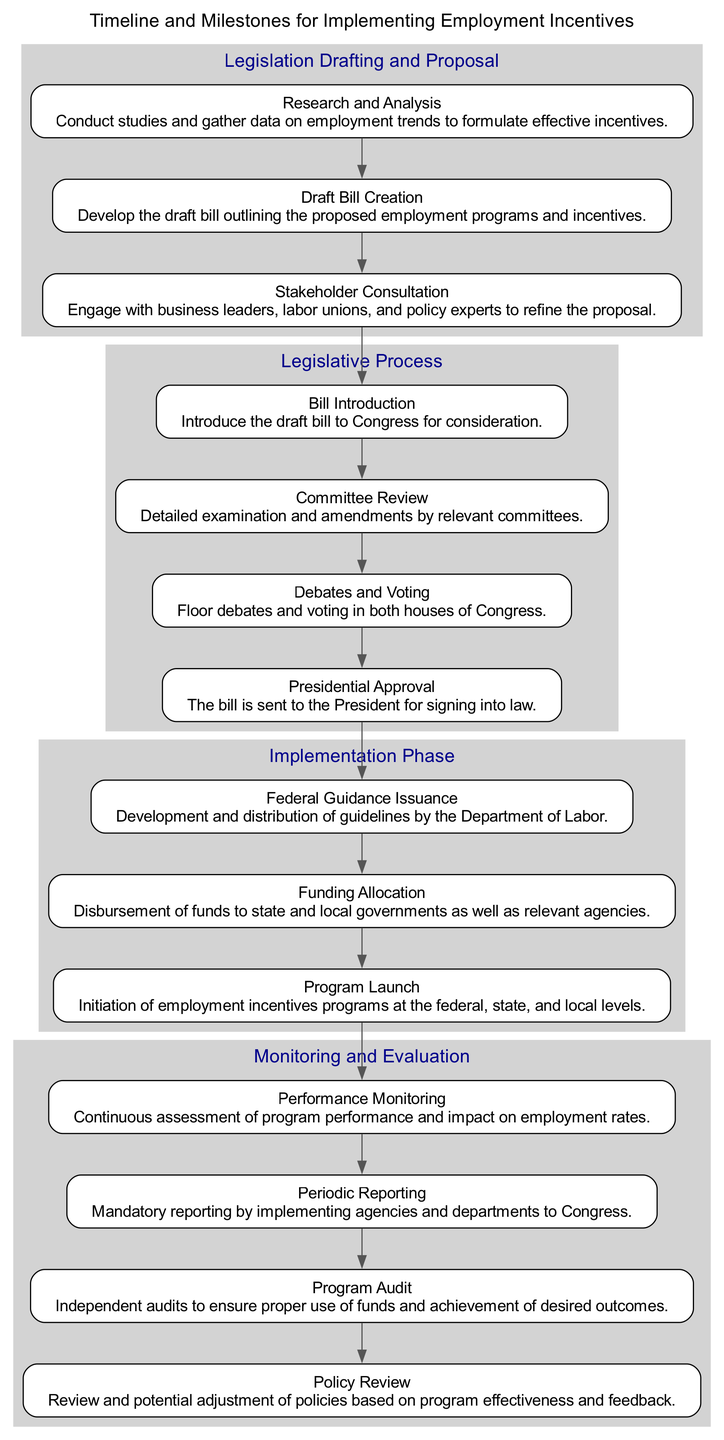What is the first milestone in the "Legislation Drafting and Proposal" block? The first milestone listed under the "Legislation Drafting and Proposal" block is "Research and Analysis." It is the first entry in the milestones array for that block.
Answer: Research and Analysis How many blocks are present in this diagram? There are four distinct blocks in the diagram, each representing a different phase of the process: "Legislation Drafting and Proposal," "Legislative Process," "Implementation Phase," and "Monitoring and Evaluation." Each block is visually separated in the diagram.
Answer: 4 What connects the last milestone of one block to the first milestone of the next block? The connection from the last milestone of one block to the first milestone of the next block is represented by directed edges. In this case, an edge connects the last milestone of "Legislation Drafting and Proposal" to the first milestone of "Legislative Process."
Answer: Directed edge Which milestone in the "Implementation Phase" involves the distribution of funds? The milestone that involves the distribution of funds is "Funding Allocation." It specifically focuses on the financial aspect of implementing the employment incentives program within the Implementation Phase block.
Answer: Funding Allocation What is the last milestone in the "Monitoring and Evaluation" block? The last milestone in the "Monitoring and Evaluation" block is "Policy Review." This milestone represents the review and potential adjustment of policies based on the evaluation of the programs.
Answer: Policy Review How many milestones are in the "Legislative Process" block? The "Legislative Process" block contains four milestones in total: "Bill Introduction," "Committee Review," "Debates and Voting," and "Presidential Approval." Each milestone is crucial in the legislative process.
Answer: 4 Which phase is the "Committee Review" milestone categorized under? The "Committee Review" milestone is categorized under the "Legislative Process" block. It comes after the "Bill Introduction" and before "Debates and Voting," reflecting its position in the legislative timeline.
Answer: Legislative Process What is the purpose of the "Program Audit" milestone? The purpose of the "Program Audit" milestone is to conduct independent audits to ensure proper use of funds and the achievement of desired outcomes of the employment incentives programs. It is part of the "Monitoring and Evaluation" block.
Answer: Independent audits 